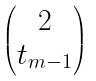<formula> <loc_0><loc_0><loc_500><loc_500>\begin{pmatrix} 2 \\ t _ { m - 1 } \end{pmatrix}</formula> 